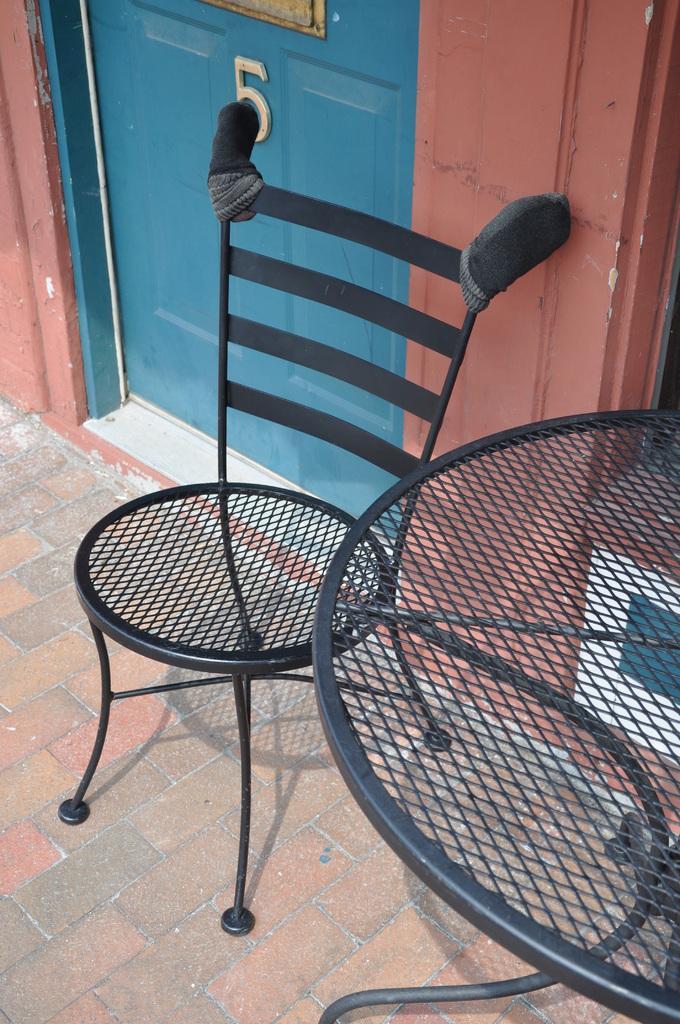Can you describe this image briefly? In this picture i can see the black color steel chair and table. Beside that there is a blue color door and wall. 